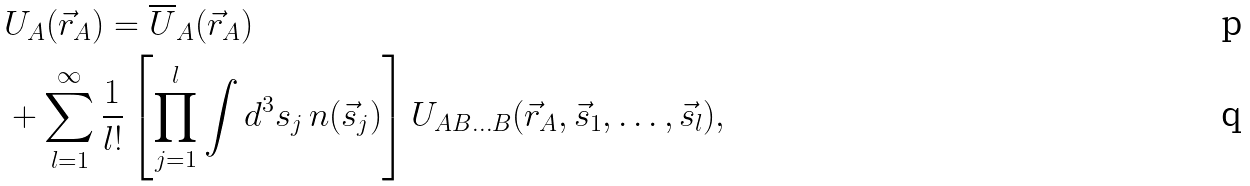<formula> <loc_0><loc_0><loc_500><loc_500>& U _ { A } ( \vec { r } _ { A } ) = \overline { U } _ { A } ( \vec { r } _ { A } ) \\ & + \sum _ { l = 1 } ^ { \infty } \frac { 1 } { l ! } \left [ \prod _ { j = 1 } ^ { l } \int d ^ { 3 } s _ { j } \, n ( \vec { s } _ { j } ) \right ] U _ { A B \dots B } ( \vec { r } _ { A } , \vec { s } _ { 1 } , \dots , \vec { s } _ { l } ) ,</formula> 